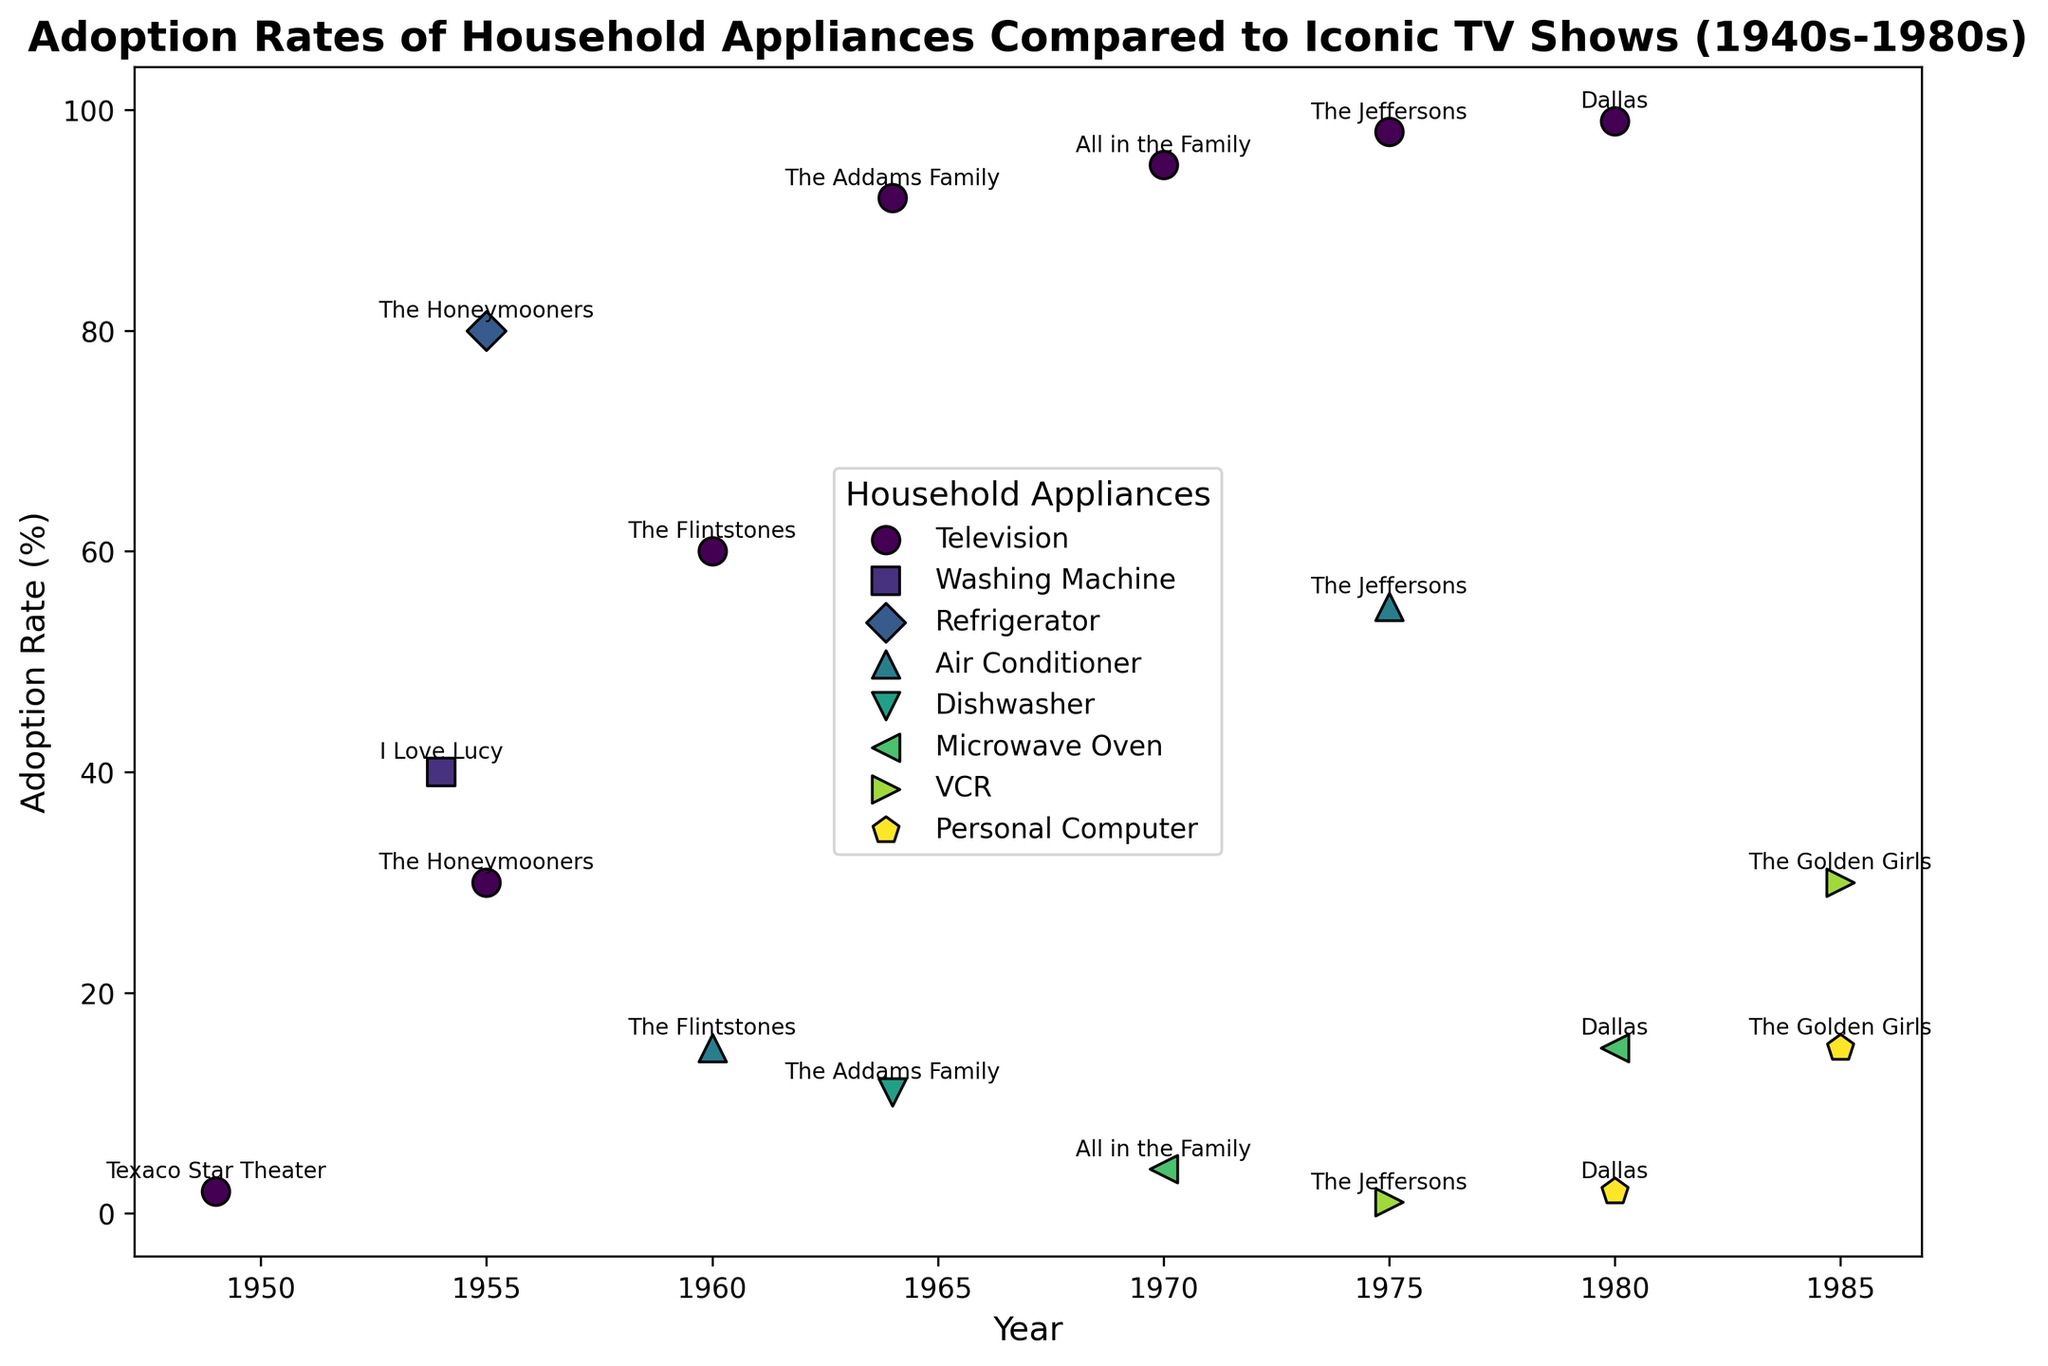What is the highest adoption rate of televisions depicted in the figure? Identify the marker for televisions and find the highest point on the Y-axis. The highest adoption rate for television is in 1980.
Answer: 99% Which household appliance had the lowest adoption rate in 1970? Locate the points for 1970 and compare the adoption rates of different household appliances. The VCR had the lowest adoption rate.
Answer: VCR In which year did air conditioners see a significant increase in adoption rate compared to a previous year indicated in the figure? Compare the adoption rates of air conditioners in different years. The adoption rate jumped from 15% in 1960 to 55% in 1975.
Answer: 1975 Which TV show corresponded with a 95% television adoption rate? Look for the annotation closest to the 95% adoption rate for televisions. The corresponding TV show is "All in the Family".
Answer: All in the Family Compare the adoption rates of washing machines and dishwashers. Which was higher, and in what years are they compared? The adoption rate for washing machines in 1954 is 40%, and for dishwashers in 1964, it is 11%. The washing machine had a higher adoption rate.
Answer: Washing machines, 1954 vs. 1964 What is the adoption rate of personal computers in 1985? Identify the marker for personal computers and find the point on the Y-axis for 1985. The adoption rate is 15%.
Answer: 15% Which appliance had a significant increase in adoption from its introduction to 1975? Compare the adoption rates of appliances from their initial appearance in the data to 1975. The air conditioner increased from 15% in 1960 to 55% in 1975.
Answer: Air conditioner What is the median adoption rate for all household appliances in 1980? List the adoption rates for household appliances in 1980 (excluding TV: personal computer 2%, microwave oven 15%). The median is the middle value of 2%, 15%, so the median is (2% + 15%) / 2 = 8.5%.
Answer: 8.5% How do the adoption rates of televisions compare between 1949 and 1980? Find the adoption rates for televisions in 1949 and 1980. The rates are 2% in 1949 and 99% in 1980. The 1980 rate is much higher.
Answer: 1980 is significantly higher than 1949 